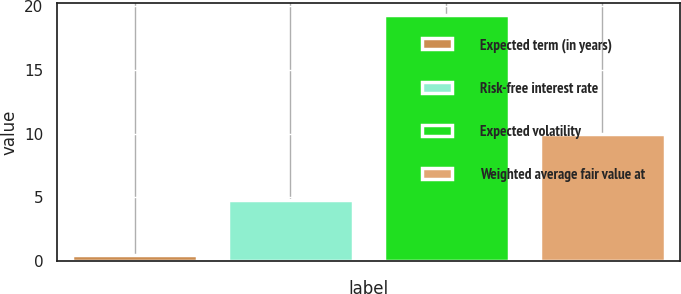<chart> <loc_0><loc_0><loc_500><loc_500><bar_chart><fcel>Expected term (in years)<fcel>Risk-free interest rate<fcel>Expected volatility<fcel>Weighted average fair value at<nl><fcel>0.5<fcel>4.8<fcel>19.3<fcel>9.94<nl></chart> 